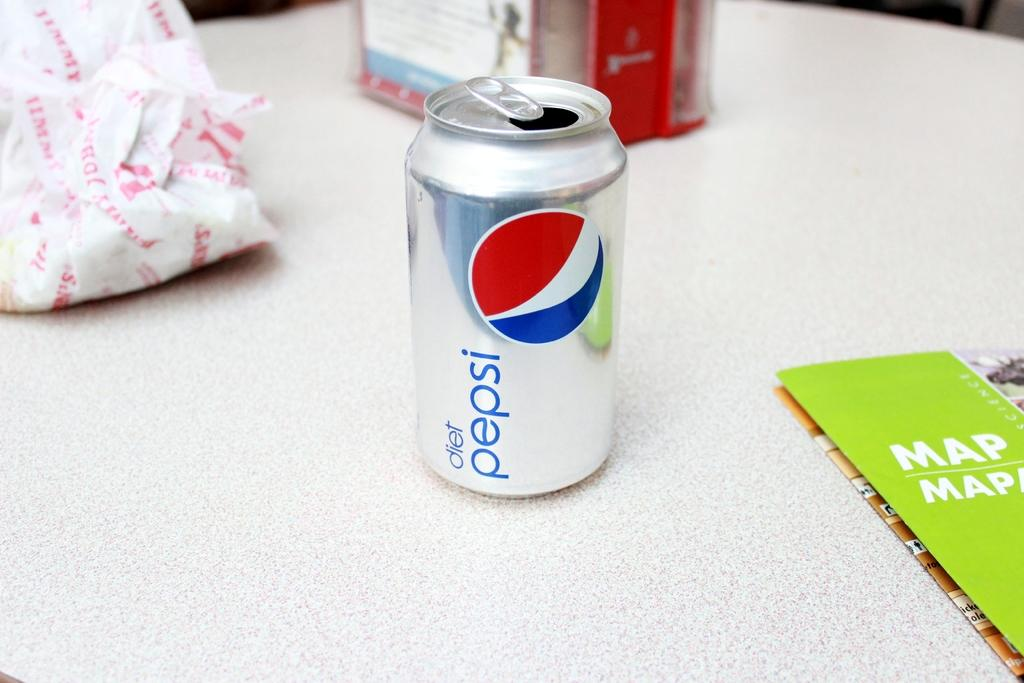<image>
Give a short and clear explanation of the subsequent image. an aluminum can of diet pepsi sits open on a desk 